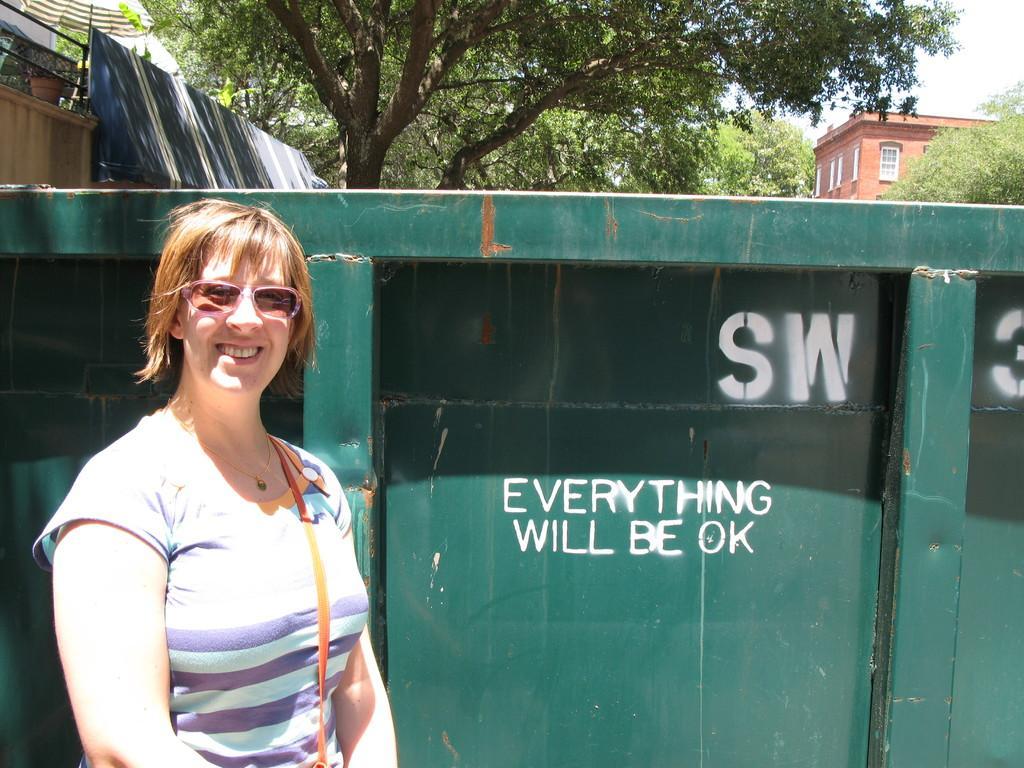In one or two sentences, can you explain what this image depicts? In this picture we can see a woman, she is smiling, she is wearing a goggles, at the back of her we can see a fence, buildings, pot, umbrella, sheet and trees and we can see sky in the background. 